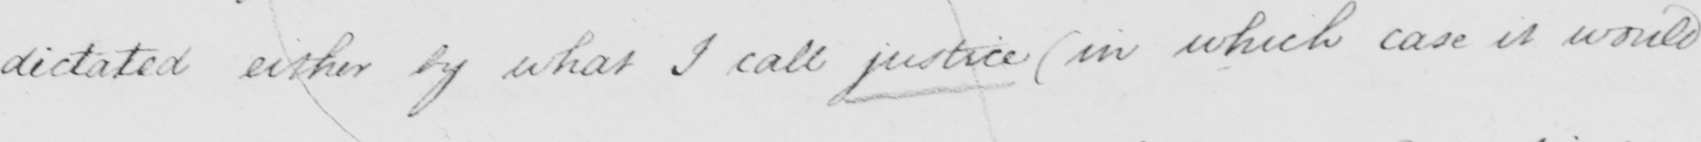What does this handwritten line say? dictated either by what I call justice (in which case it would 